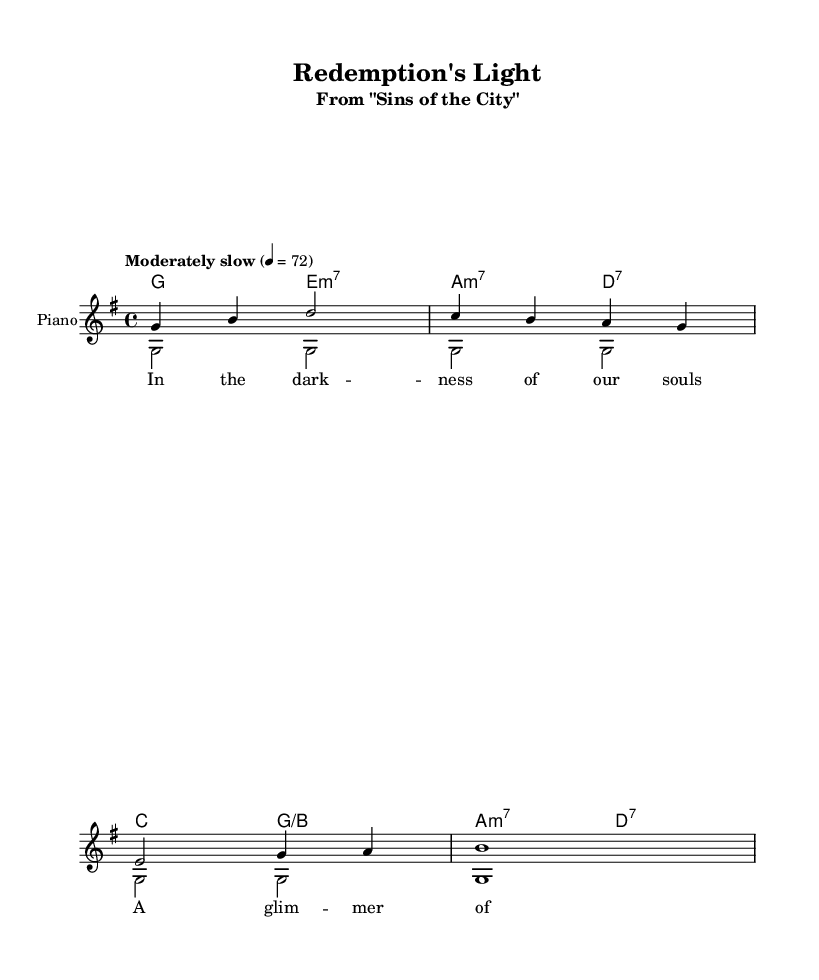What is the key signature of this music? The key signature indicates one sharp in the key of G major, which corresponds to the "F#" note notated in the music.
Answer: G major What is the time signature of this music? The time signature is indicated at the beginning of the score and refers to the beats per measure; in this case, it shows that there are four beats in each measure.
Answer: 4/4 What is the tempo marking? The tempo marking is found at the beginning of the score and it specifies the speed of the music, which in this case is indicated as "Moderately slow" at a metronome marking of 72 beats per minute.
Answer: Moderately slow What is the first chord in the piece? The first chord is indicated at the start of the harmony section, and it matches the melody note G, which is accompanied by E minor seventh, forming the G chord.
Answer: E minor seventh How many measures are in the melody section? To determine the number of measures, we can count the individual bar lines in the melody; each corresponds to one measure. The melody contains a total of four measures.
Answer: 4 What is the vocal texture of this arrangement? The vocal texture can be identified by looking for the different voice indications in the score; thus, seeing both a melody and an accompaniment suggests a two-part harmony arrangement.
Answer: Two-part harmony What is the significance of the lyrics in this piece? The lyrics describe themes of hope and redemption, which are commonly found in gospel music and often convey spiritual messages. By analyzing the textual content, we can see that it reflects the overarching themes often explored in religious music.
Answer: Hope and redemption 